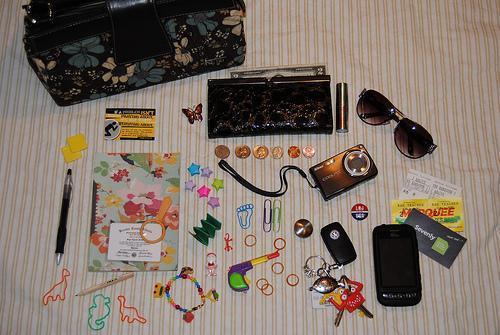How many cameras are there?
Give a very brief answer. 1. 